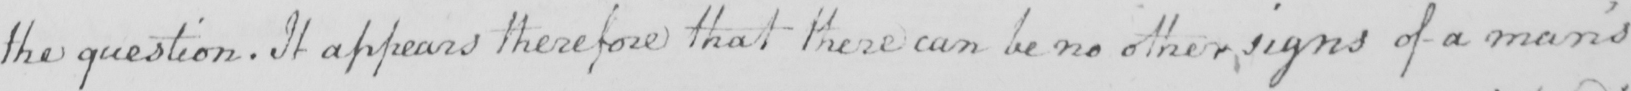What is written in this line of handwriting? the question . It appears therefore that these can be no other signs of a man ' s 